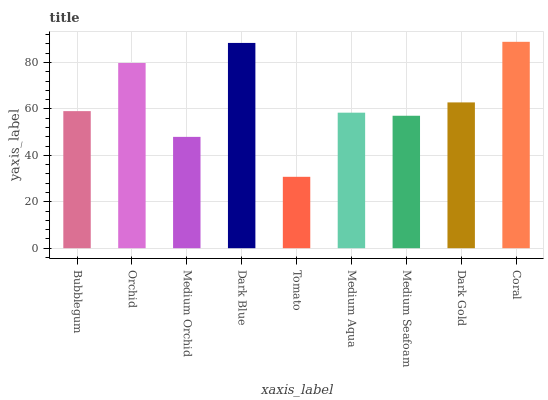Is Orchid the minimum?
Answer yes or no. No. Is Orchid the maximum?
Answer yes or no. No. Is Orchid greater than Bubblegum?
Answer yes or no. Yes. Is Bubblegum less than Orchid?
Answer yes or no. Yes. Is Bubblegum greater than Orchid?
Answer yes or no. No. Is Orchid less than Bubblegum?
Answer yes or no. No. Is Bubblegum the high median?
Answer yes or no. Yes. Is Bubblegum the low median?
Answer yes or no. Yes. Is Medium Orchid the high median?
Answer yes or no. No. Is Coral the low median?
Answer yes or no. No. 